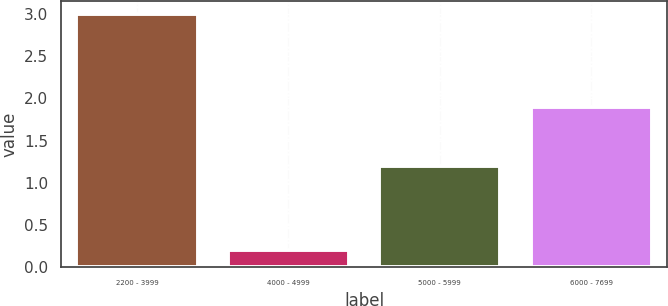Convert chart. <chart><loc_0><loc_0><loc_500><loc_500><bar_chart><fcel>2200 - 3999<fcel>4000 - 4999<fcel>5000 - 5999<fcel>6000 - 7699<nl><fcel>3<fcel>0.2<fcel>1.2<fcel>1.9<nl></chart> 